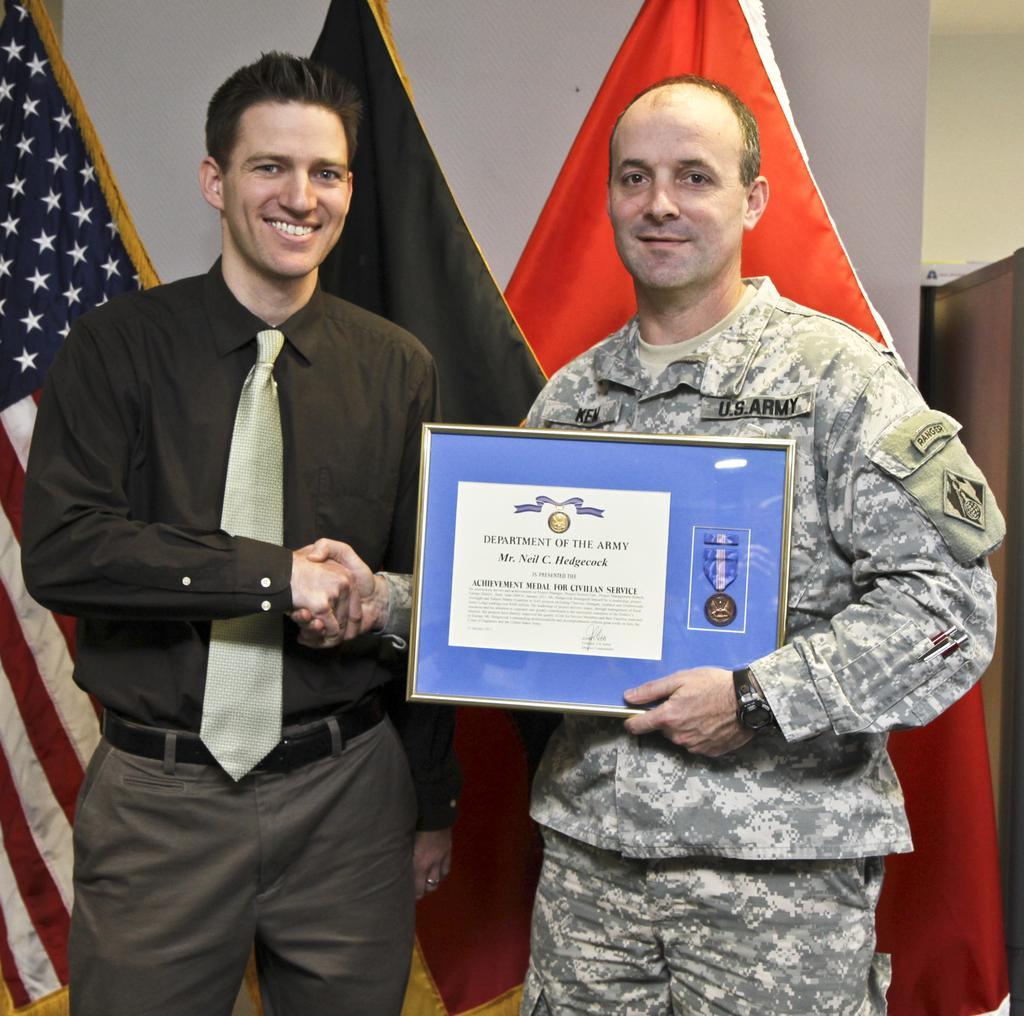Please provide a concise description of this image. In this image there is a person wearing a black shirt and tie. He is standing. He is shaking the hand of a person. He is holding the shield. Behind them there are flags. Background there is a wall. 